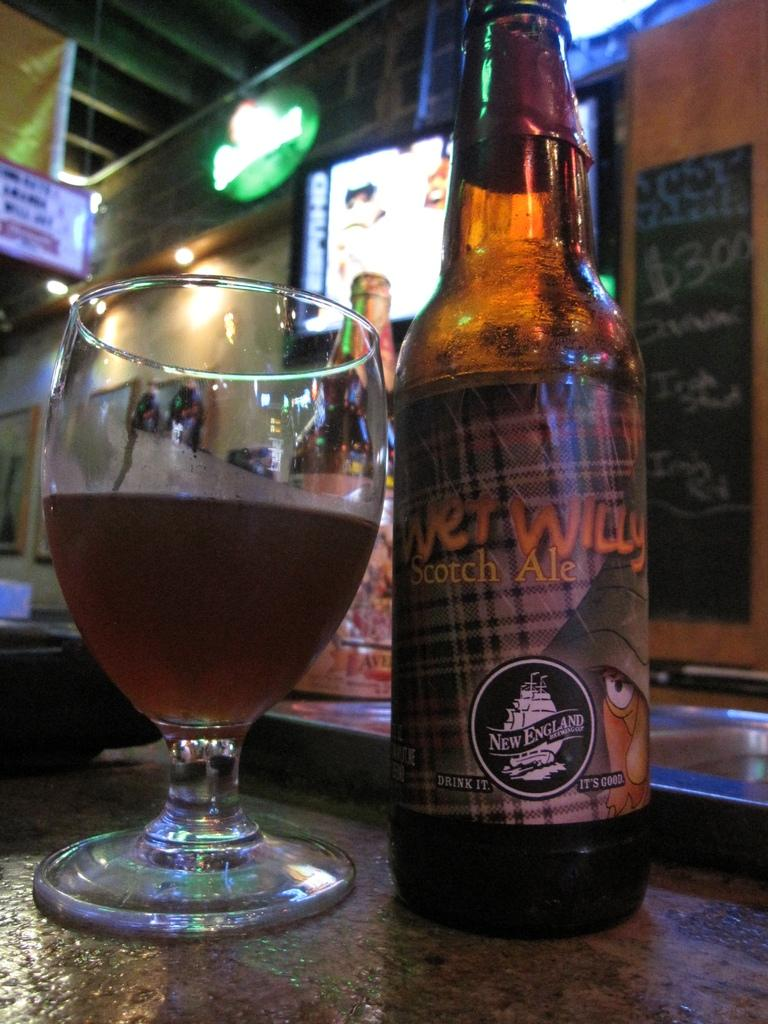Provide a one-sentence caption for the provided image. Bottle of Wet Willy Scotch Ale from New England. 